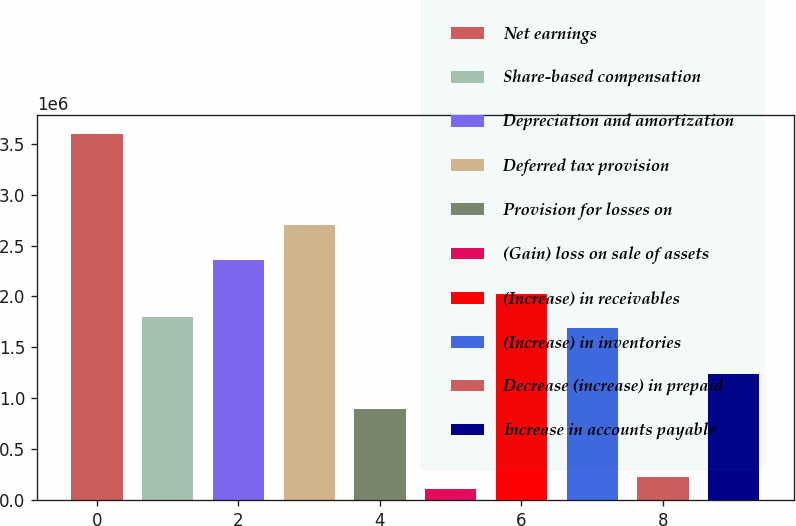Convert chart. <chart><loc_0><loc_0><loc_500><loc_500><bar_chart><fcel>Net earnings<fcel>Share-based compensation<fcel>Depreciation and amortization<fcel>Deferred tax provision<fcel>Provision for losses on<fcel>(Gain) loss on sale of assets<fcel>(Increase) in receivables<fcel>(Increase) in inventories<fcel>Decrease (increase) in prepaid<fcel>Increase in accounts payable<nl><fcel>3.59826e+06<fcel>1.79929e+06<fcel>2.36147e+06<fcel>2.69877e+06<fcel>899808<fcel>112760<fcel>2.02416e+06<fcel>1.68686e+06<fcel>225196<fcel>1.23711e+06<nl></chart> 